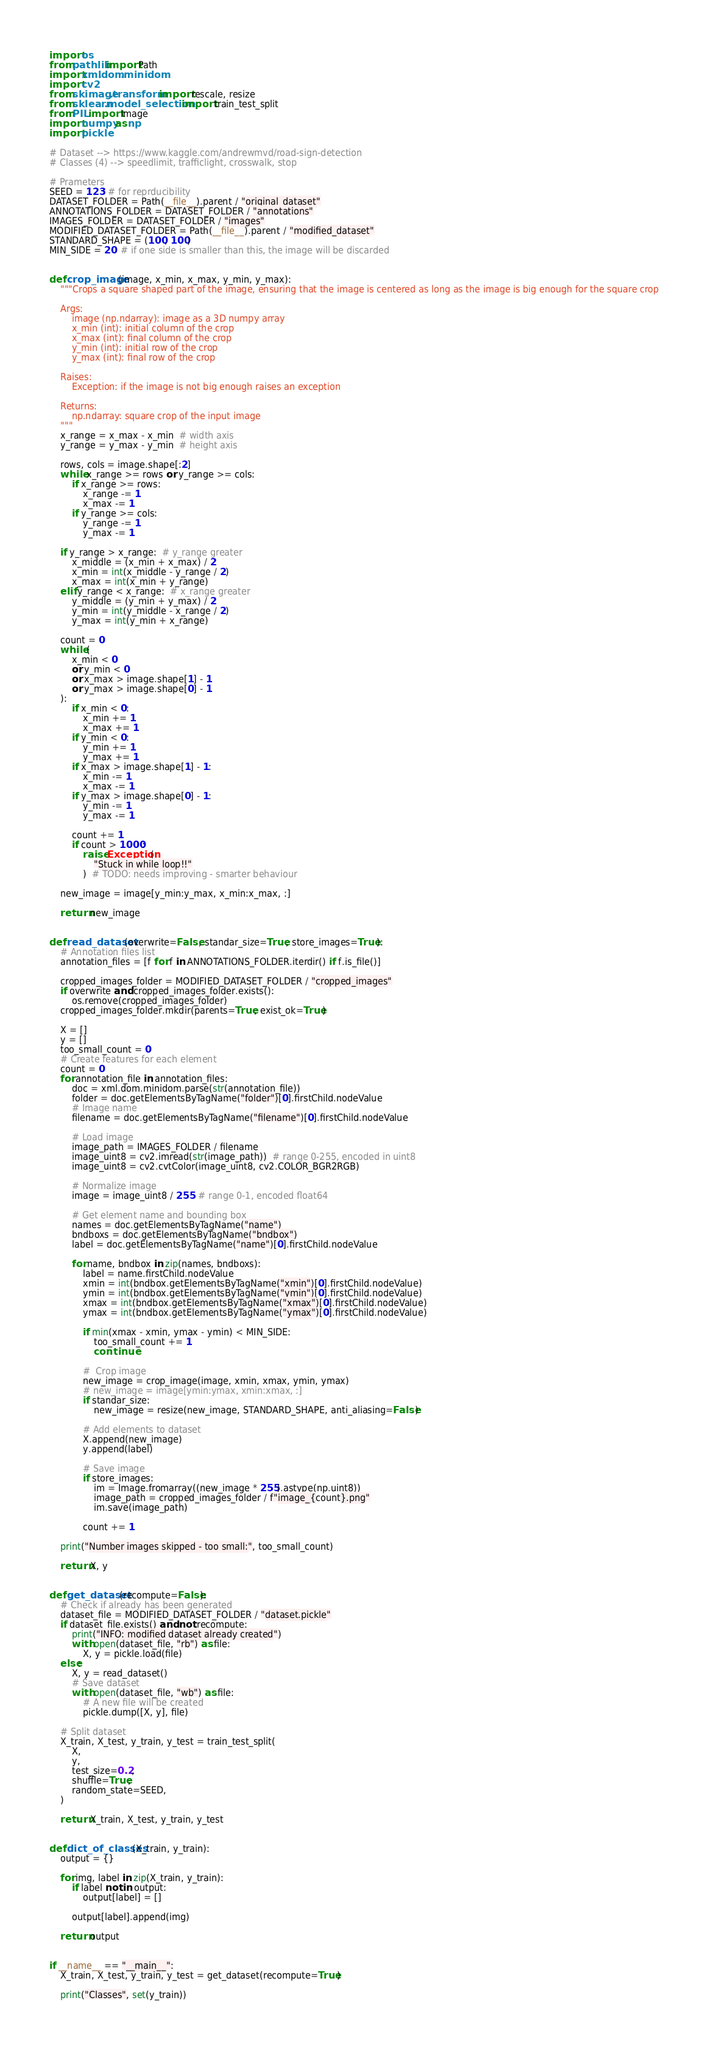Convert code to text. <code><loc_0><loc_0><loc_500><loc_500><_Python_>import os
from pathlib import Path
import xml.dom.minidom
import cv2
from skimage.transform import rescale, resize
from sklearn.model_selection import train_test_split
from PIL import Image
import numpy as np
import pickle

# Dataset --> https://www.kaggle.com/andrewmvd/road-sign-detection
# Classes (4) --> speedlimit, trafficlight, crosswalk, stop

# Prameters
SEED = 123  # for reprducibility
DATASET_FOLDER = Path(__file__).parent / "original_dataset"
ANNOTATIONS_FOLDER = DATASET_FOLDER / "annotations"
IMAGES_FOLDER = DATASET_FOLDER / "images"
MODIFIED_DATASET_FOLDER = Path(__file__).parent / "modified_dataset"
STANDARD_SHAPE = (100, 100)
MIN_SIDE = 20  # if one side is smaller than this, the image will be discarded


def crop_image(image, x_min, x_max, y_min, y_max):
    """Crops a square shaped part of the image, ensuring that the image is centered as long as the image is big enough for the square crop

    Args:
        image (np.ndarray): image as a 3D numpy array
        x_min (int): initial column of the crop
        x_max (int): final column of the crop
        y_min (int): initial row of the crop
        y_max (int): final row of the crop

    Raises:
        Exception: if the image is not big enough raises an exception

    Returns:
        np.ndarray: square crop of the input image
    """
    x_range = x_max - x_min  # width axis
    y_range = y_max - y_min  # height axis

    rows, cols = image.shape[:2]
    while x_range >= rows or y_range >= cols:
        if x_range >= rows:
            x_range -= 1
            x_max -= 1
        if y_range >= cols:
            y_range -= 1
            y_max -= 1

    if y_range > x_range:  # y_range greater
        x_middle = (x_min + x_max) / 2
        x_min = int(x_middle - y_range / 2)
        x_max = int(x_min + y_range)
    elif y_range < x_range:  # x_range greater
        y_middle = (y_min + y_max) / 2
        y_min = int(y_middle - x_range / 2)
        y_max = int(y_min + x_range)

    count = 0
    while (
        x_min < 0
        or y_min < 0
        or x_max > image.shape[1] - 1
        or y_max > image.shape[0] - 1
    ):
        if x_min < 0:
            x_min += 1
            x_max += 1
        if y_min < 0:
            y_min += 1
            y_max += 1
        if x_max > image.shape[1] - 1:
            x_min -= 1
            x_max -= 1
        if y_max > image.shape[0] - 1:
            y_min -= 1
            y_max -= 1

        count += 1
        if count > 1000:
            raise Exception(
                "Stuck in while loop!!"
            )  # TODO: needs improving - smarter behaviour

    new_image = image[y_min:y_max, x_min:x_max, :]

    return new_image


def read_dataset(overwrite=False, standar_size=True, store_images=True):
    # Annotation files list
    annotation_files = [f for f in ANNOTATIONS_FOLDER.iterdir() if f.is_file()]

    cropped_images_folder = MODIFIED_DATASET_FOLDER / "cropped_images"
    if overwrite and cropped_images_folder.exists():
        os.remove(cropped_images_folder)
    cropped_images_folder.mkdir(parents=True, exist_ok=True)

    X = []
    y = []
    too_small_count = 0
    # Create features for each element
    count = 0
    for annotation_file in annotation_files:
        doc = xml.dom.minidom.parse(str(annotation_file))
        folder = doc.getElementsByTagName("folder")[0].firstChild.nodeValue
        # Image name
        filename = doc.getElementsByTagName("filename")[0].firstChild.nodeValue

        # Load image
        image_path = IMAGES_FOLDER / filename
        image_uint8 = cv2.imread(str(image_path))  # range 0-255, encoded in uint8
        image_uint8 = cv2.cvtColor(image_uint8, cv2.COLOR_BGR2RGB)

        # Normalize image
        image = image_uint8 / 255  # range 0-1, encoded float64

        # Get element name and bounding box
        names = doc.getElementsByTagName("name")
        bndboxs = doc.getElementsByTagName("bndbox")
        label = doc.getElementsByTagName("name")[0].firstChild.nodeValue

        for name, bndbox in zip(names, bndboxs):
            label = name.firstChild.nodeValue
            xmin = int(bndbox.getElementsByTagName("xmin")[0].firstChild.nodeValue)
            ymin = int(bndbox.getElementsByTagName("ymin")[0].firstChild.nodeValue)
            xmax = int(bndbox.getElementsByTagName("xmax")[0].firstChild.nodeValue)
            ymax = int(bndbox.getElementsByTagName("ymax")[0].firstChild.nodeValue)

            if min(xmax - xmin, ymax - ymin) < MIN_SIDE:
                too_small_count += 1
                continue

            #  Crop image
            new_image = crop_image(image, xmin, xmax, ymin, ymax)
            # new_image = image[ymin:ymax, xmin:xmax, :]
            if standar_size:
                new_image = resize(new_image, STANDARD_SHAPE, anti_aliasing=False)

            # Add elements to dataset
            X.append(new_image)
            y.append(label)

            # Save image
            if store_images:
                im = Image.fromarray((new_image * 255).astype(np.uint8))
                image_path = cropped_images_folder / f"image_{count}.png"
                im.save(image_path)

            count += 1

    print("Number images skipped - too small:", too_small_count)

    return X, y


def get_dataset(recompute=False):
    # Check if already has been generated
    dataset_file = MODIFIED_DATASET_FOLDER / "dataset.pickle"
    if dataset_file.exists() and not recompute:
        print("INFO: modified dataset already created")
        with open(dataset_file, "rb") as file:
            X, y = pickle.load(file)
    else:
        X, y = read_dataset()
        # Save dataset
        with open(dataset_file, "wb") as file:
            # A new file will be created
            pickle.dump([X, y], file)

    # Split dataset
    X_train, X_test, y_train, y_test = train_test_split(
        X,
        y,
        test_size=0.2,
        shuffle=True,
        random_state=SEED,
    )

    return X_train, X_test, y_train, y_test


def dict_of_classes(X_train, y_train):
    output = {}

    for img, label in zip(X_train, y_train):
        if label not in output:
            output[label] = []

        output[label].append(img)

    return output


if __name__ == "__main__":
    X_train, X_test, y_train, y_test = get_dataset(recompute=True)

    print("Classes", set(y_train))
</code> 